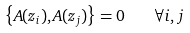<formula> <loc_0><loc_0><loc_500><loc_500>\left \{ A ( z _ { i } ) , A ( z _ { j } ) \right \} = 0 \quad \forall i , j</formula> 